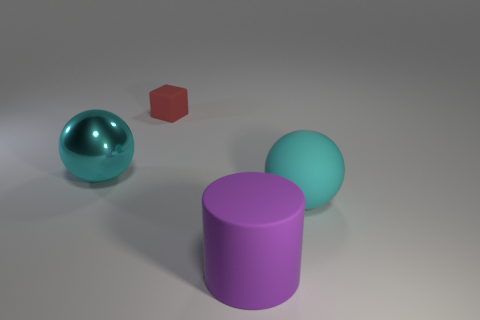Is there any other thing that is the same size as the red thing?
Your response must be concise. No. Is there any other thing that is the same shape as the tiny matte thing?
Keep it short and to the point. No. What shape is the shiny object that is the same color as the rubber ball?
Provide a succinct answer. Sphere. What material is the cyan object that is behind the rubber object that is on the right side of the purple matte cylinder?
Keep it short and to the point. Metal. There is a thing that is both to the left of the large purple object and to the right of the cyan metal ball; what is its size?
Your answer should be compact. Small. There is another large cyan thing that is the same shape as the cyan matte thing; what is its material?
Make the answer very short. Metal. Do the matte thing that is left of the purple thing and the cyan rubber ball have the same size?
Your answer should be very brief. No. What color is the matte thing that is on the left side of the large rubber sphere and behind the purple cylinder?
Offer a very short reply. Red. How many big cyan matte things are to the left of the cyan sphere in front of the shiny thing?
Provide a short and direct response. 0. Does the big cyan shiny object have the same shape as the big cyan matte object?
Give a very brief answer. Yes. 